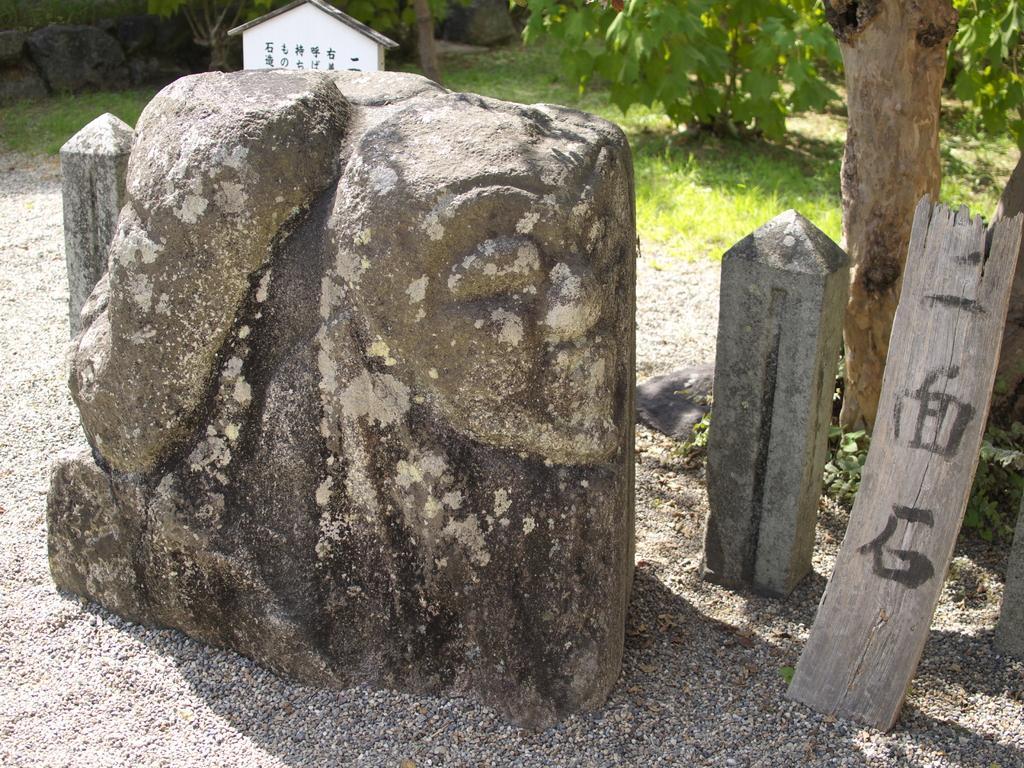How would you summarize this image in a sentence or two? We can see a big stone,small concrete poles,wooden log and a truncated tree on the right side are on the sand. In the background there is a tiny hut,plants,stones and grass on the ground. 